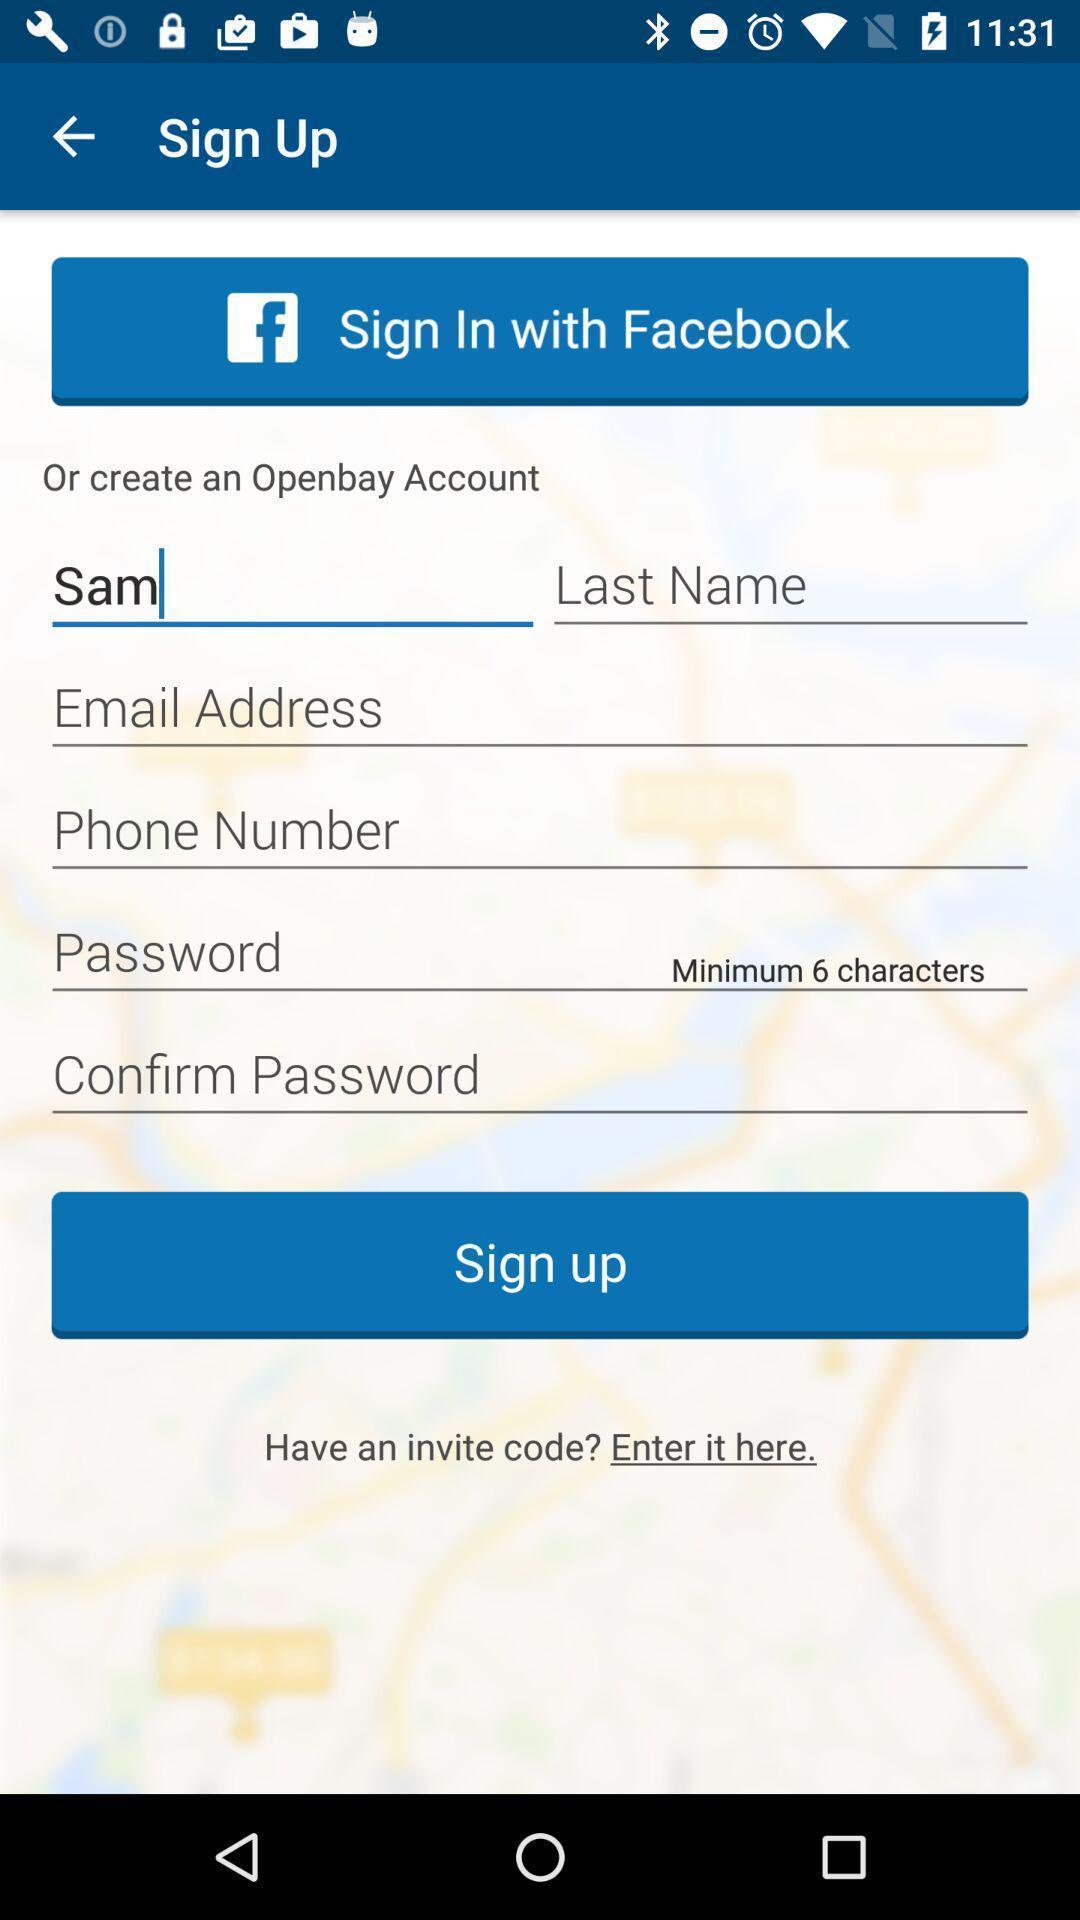Provide a textual representation of this image. Sign up page. 